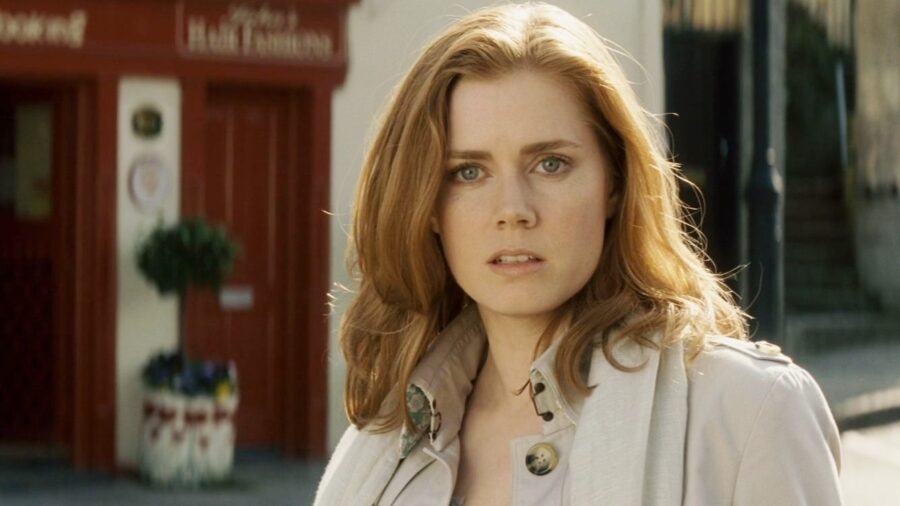Imagine a detailed backstory for this scene. In this imagined backstory, the woman is a celebrated artist named Eleanor, who is returning to her hometown after a successful exhibition abroad. The red storefront behind her is her family’s old flower shop, a place filled with childhood memories and lasting influences on her artwork. Today, she walks the familiar streets, reflecting on how far she has come. Her parents' meticulous care for the shop and their dedication to their craft inspired her, leading her to pursue her passion for painting. The brooch on her trench coat was a gift from her late grandmother, symbolizing familial love and artistic legacy. What kind of artwork might Eleanor create, inspired by her surroundings? Eleanor's artwork might be vibrant and full of life, inspired by the rich colors and textures of her surroundings. She could create expressive urban landscapes, highlighting the intricate details of city life interwoven with nature. Her paintings might capture the warmth and charm of small businesses, the vibrant hues of storefronts, and the lush greens of plants. Each piece could tell a story of bustling life and peaceful moments, much like the scene she stands in. If Eleanor’s story were made into a movie, what kind of scenes would you expect? If Eleanor’s story were made into a movie, I would expect scenes rich with visual storytelling. There would be scenes of Eleanor passionately painting in her studio, interlaced with flashes of her childhood in the flower shop. We might see her walking through different urban settings, drawing inspiration from the city’s pulse. Intimate moments with family and friends, and perhaps poignant, silent scenes of her standing in significant locations lost in thought, would add emotional depth. The film could culminate in an exhibition where her art is revealed, showing a tapestry of her journey, emotions, and the vivid life moments that shaped her creations. 